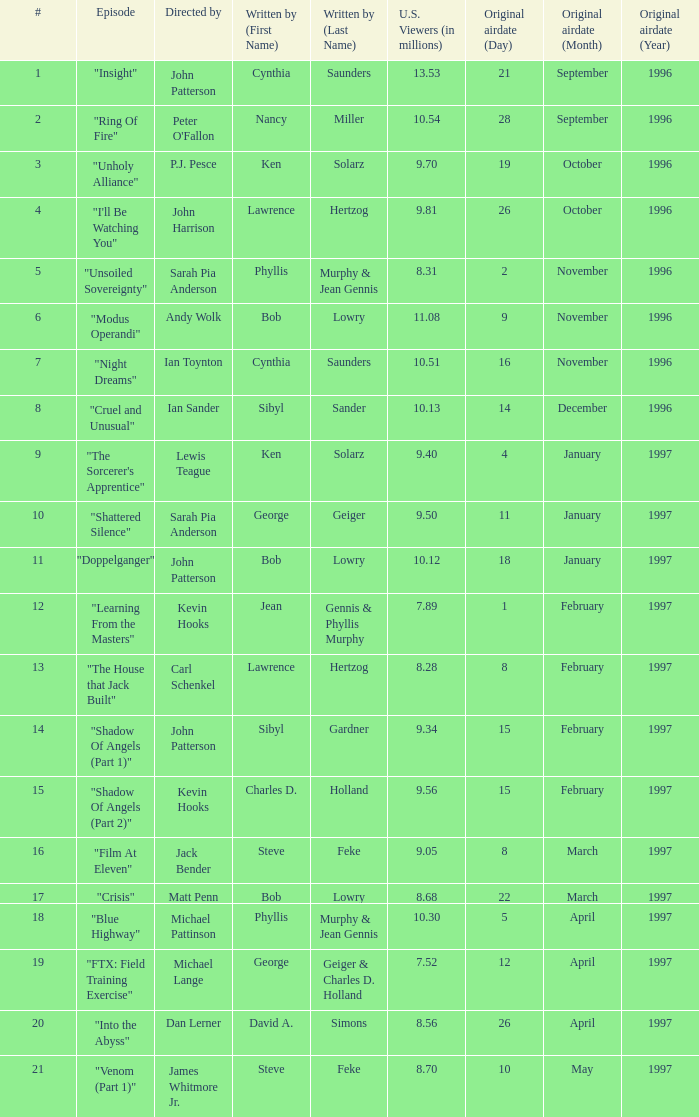What are the titles of episodes numbered 19? "FTX: Field Training Exercise". 